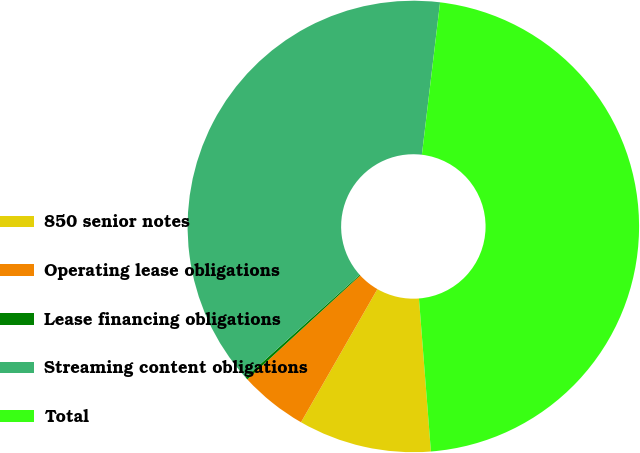Convert chart. <chart><loc_0><loc_0><loc_500><loc_500><pie_chart><fcel>850 senior notes<fcel>Operating lease obligations<fcel>Lease financing obligations<fcel>Streaming content obligations<fcel>Total<nl><fcel>9.53%<fcel>4.86%<fcel>0.19%<fcel>38.55%<fcel>46.87%<nl></chart> 